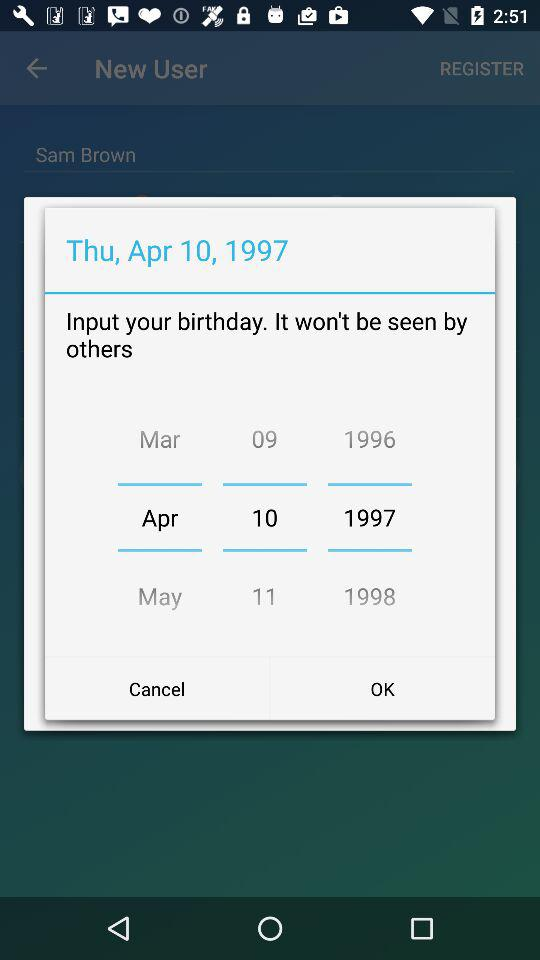What is the user's name? The user's name is Sam Brown. 